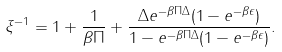<formula> <loc_0><loc_0><loc_500><loc_500>\xi ^ { - 1 } = 1 + \frac { 1 } { \beta \Pi } + \frac { \Delta e ^ { - \beta \Pi \Delta } ( 1 - e ^ { - \beta \epsilon } ) } { 1 - e ^ { - \beta \Pi \Delta } ( 1 - e ^ { - \beta \epsilon } ) } .</formula> 